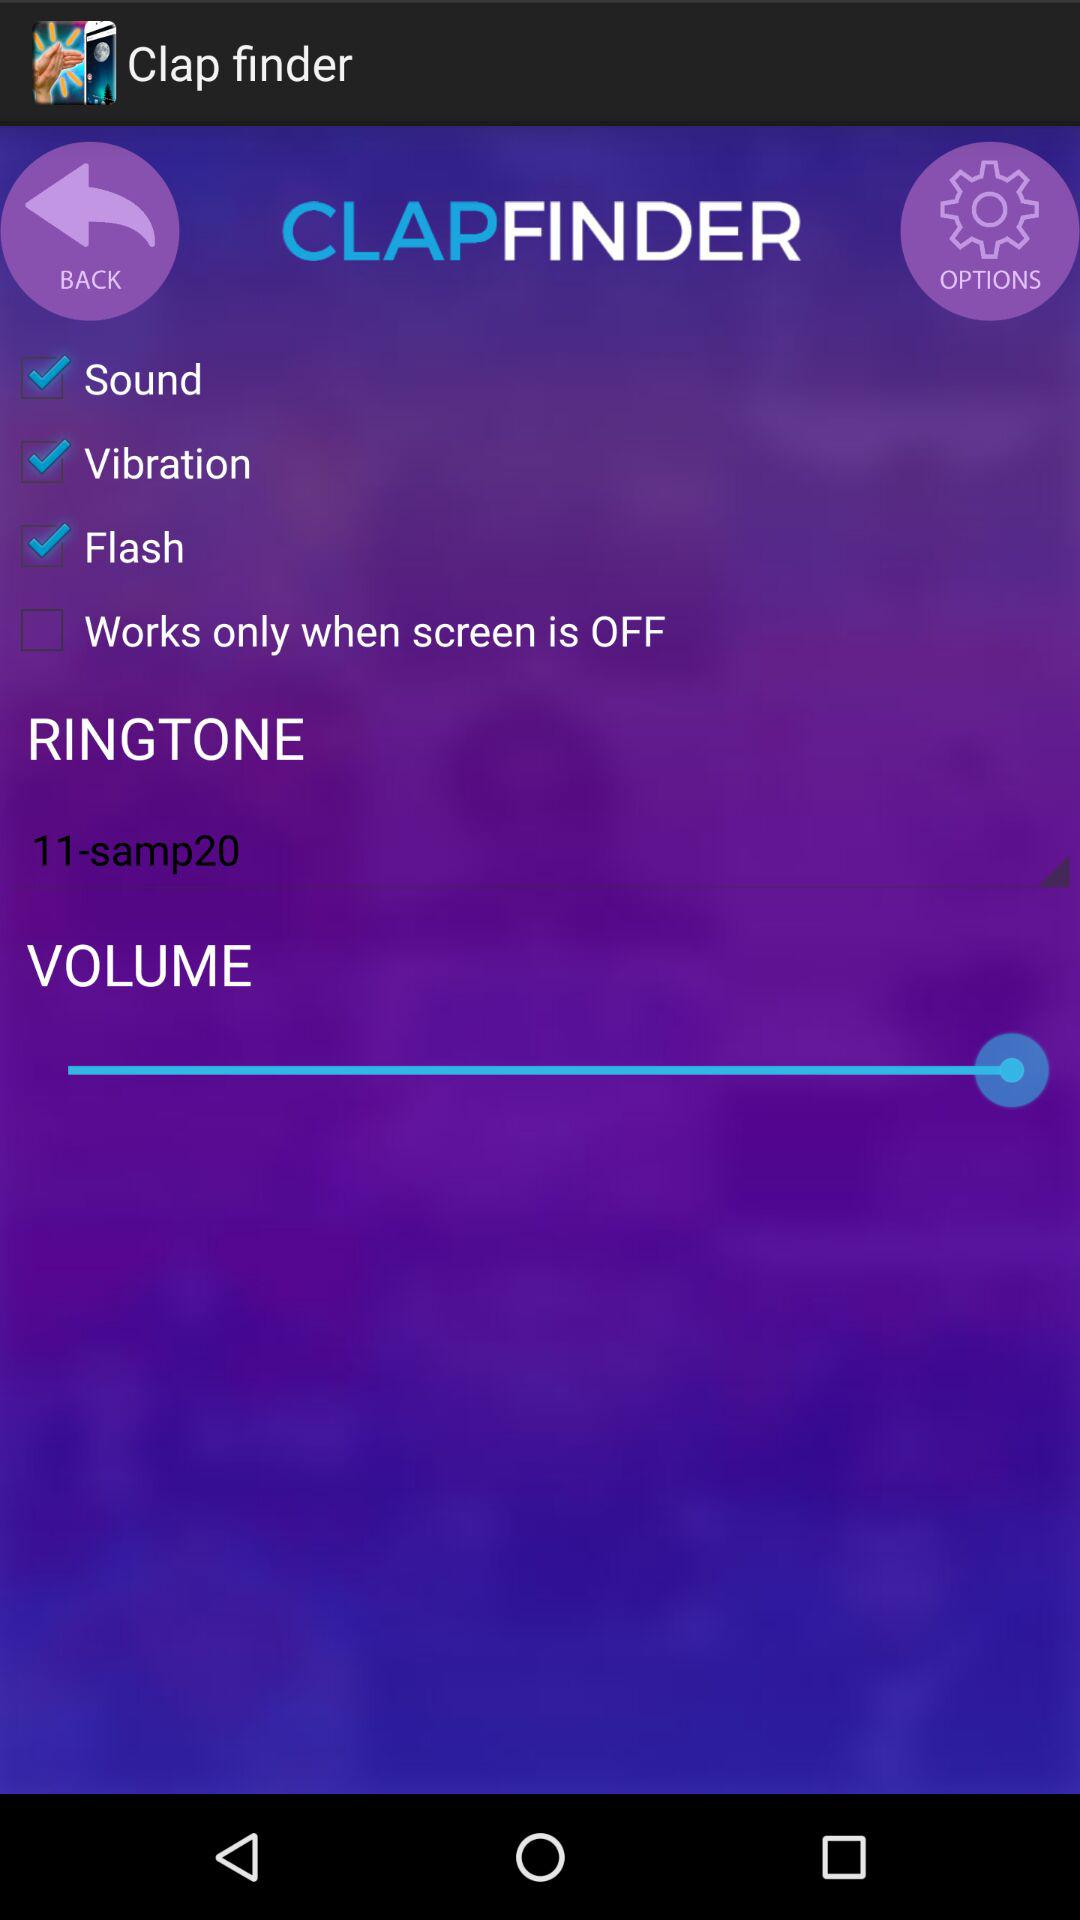What is the name of the chosen ringtone? The name of the chosen ringtone is "11-samp20". 